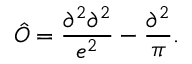<formula> <loc_0><loc_0><loc_500><loc_500>\hat { O } = \frac { \partial ^ { 2 } \partial ^ { 2 } } { e ^ { 2 } } - \frac { \partial ^ { 2 } } { \pi } .</formula> 